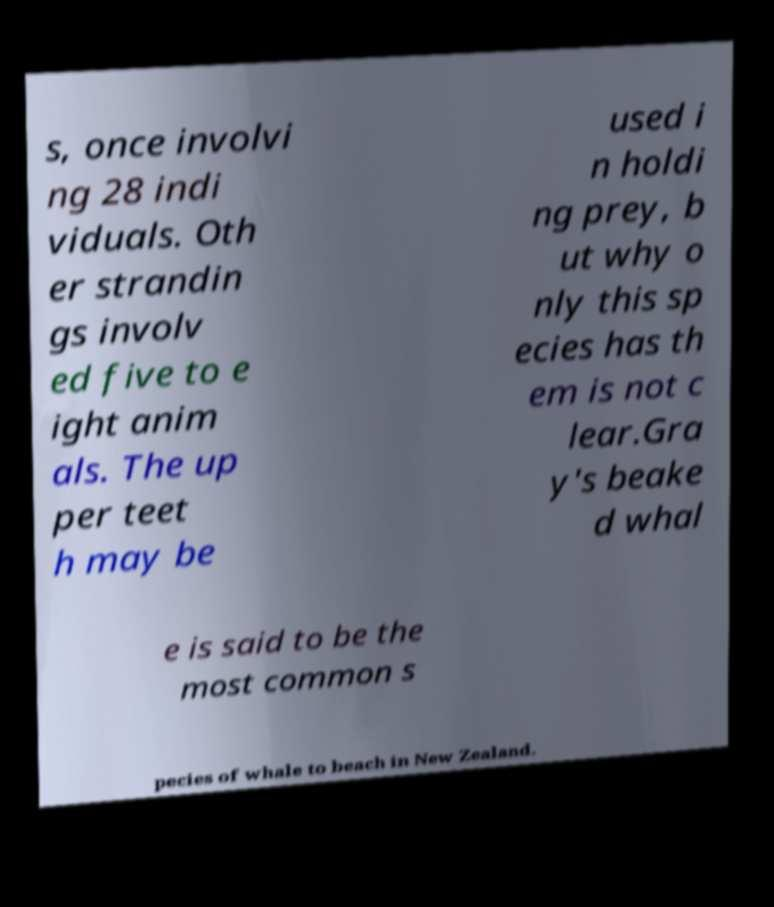For documentation purposes, I need the text within this image transcribed. Could you provide that? s, once involvi ng 28 indi viduals. Oth er strandin gs involv ed five to e ight anim als. The up per teet h may be used i n holdi ng prey, b ut why o nly this sp ecies has th em is not c lear.Gra y's beake d whal e is said to be the most common s pecies of whale to beach in New Zealand. 